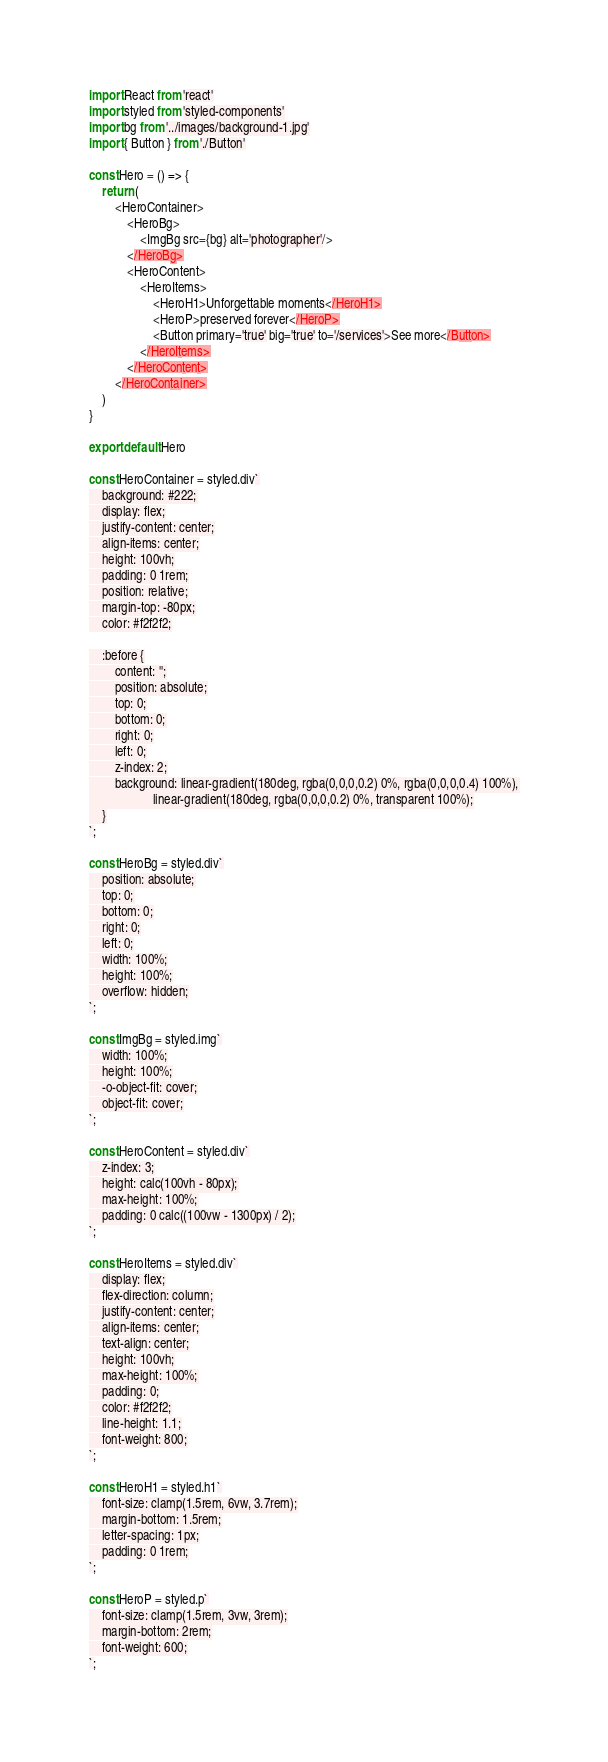<code> <loc_0><loc_0><loc_500><loc_500><_JavaScript_>import React from 'react'
import styled from 'styled-components'
import bg from '../images/background-1.jpg'
import { Button } from './Button'

const Hero = () => {
    return (
        <HeroContainer>
            <HeroBg>
                <ImgBg src={bg} alt='photographer'/>
            </HeroBg>
            <HeroContent>
                <HeroItems>
                    <HeroH1>Unforgettable moments</HeroH1>
                    <HeroP>preserved forever</HeroP>
                    <Button primary='true' big='true' to='/services'>See more</Button>
                </HeroItems>
            </HeroContent>
        </HeroContainer>
    )
}

export default Hero

const HeroContainer = styled.div`
    background: #222;
    display: flex;
    justify-content: center;
    align-items: center;
    height: 100vh;
    padding: 0 1rem;
    position: relative;
    margin-top: -80px;
    color: #f2f2f2;

    :before {
        content: '';
        position: absolute;
        top: 0;
        bottom: 0;
        right: 0;
        left: 0;
        z-index: 2;
        background: linear-gradient(180deg, rgba(0,0,0,0.2) 0%, rgba(0,0,0,0.4) 100%),
                    linear-gradient(180deg, rgba(0,0,0,0.2) 0%, transparent 100%);
    }
`;

const HeroBg = styled.div`
    position: absolute;
    top: 0;
    bottom: 0;
    right: 0;
    left: 0;
    width: 100%;
    height: 100%;
    overflow: hidden;
`;

const ImgBg = styled.img`
    width: 100%;
    height: 100%;
    -o-object-fit: cover;
    object-fit: cover;
`;

const HeroContent = styled.div`
    z-index: 3;
    height: calc(100vh - 80px);
    max-height: 100%;
    padding: 0 calc((100vw - 1300px) / 2);
`;

const HeroItems = styled.div`
    display: flex;
    flex-direction: column;
    justify-content: center;
    align-items: center;
    text-align: center;
    height: 100vh;
    max-height: 100%;
    padding: 0;
    color: #f2f2f2;
    line-height: 1.1;
    font-weight: 800;
`;

const HeroH1 = styled.h1`
    font-size: clamp(1.5rem, 6vw, 3.7rem);
    margin-bottom: 1.5rem;
    letter-spacing: 1px;
    padding: 0 1rem;
`;

const HeroP = styled.p`
    font-size: clamp(1.5rem, 3vw, 3rem);
    margin-bottom: 2rem;
    font-weight: 600;
`;


</code> 